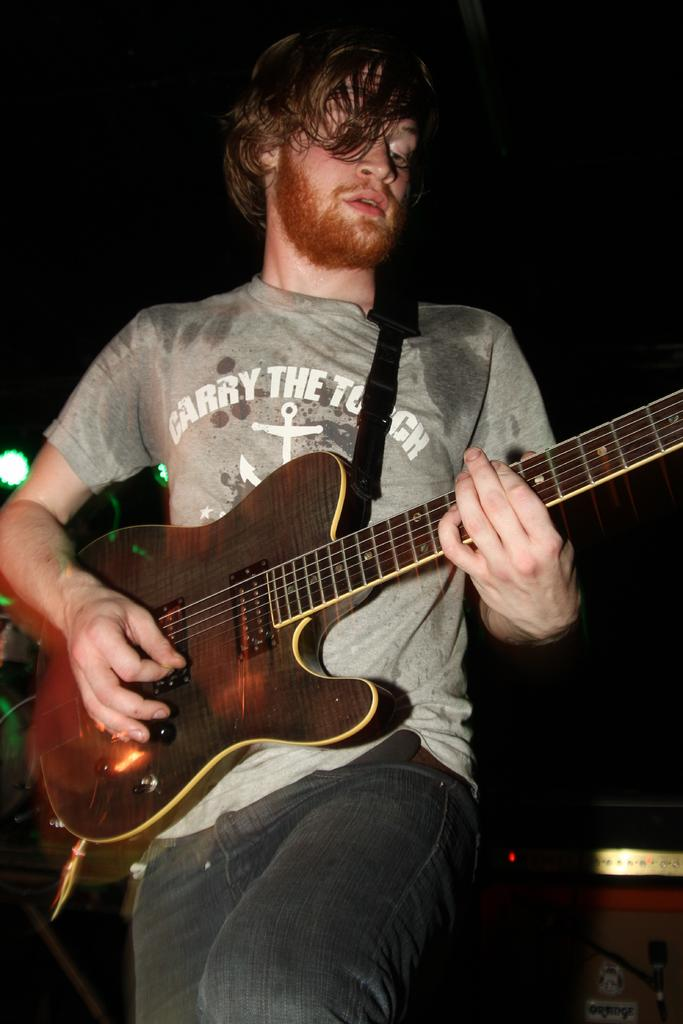What is the main subject of the image? There is a person in the image. What is the person doing in the image? The person is playing a guitar. What else can be seen in the image besides the person? There are music control systems in the image. What can be observed about the background of the image? The background at the top of the image is dark. What type of coach can be seen in the image? There is no coach present in the image. What organization is responsible for the music control systems in the image? The image does not provide information about the organization responsible for the music control systems. 